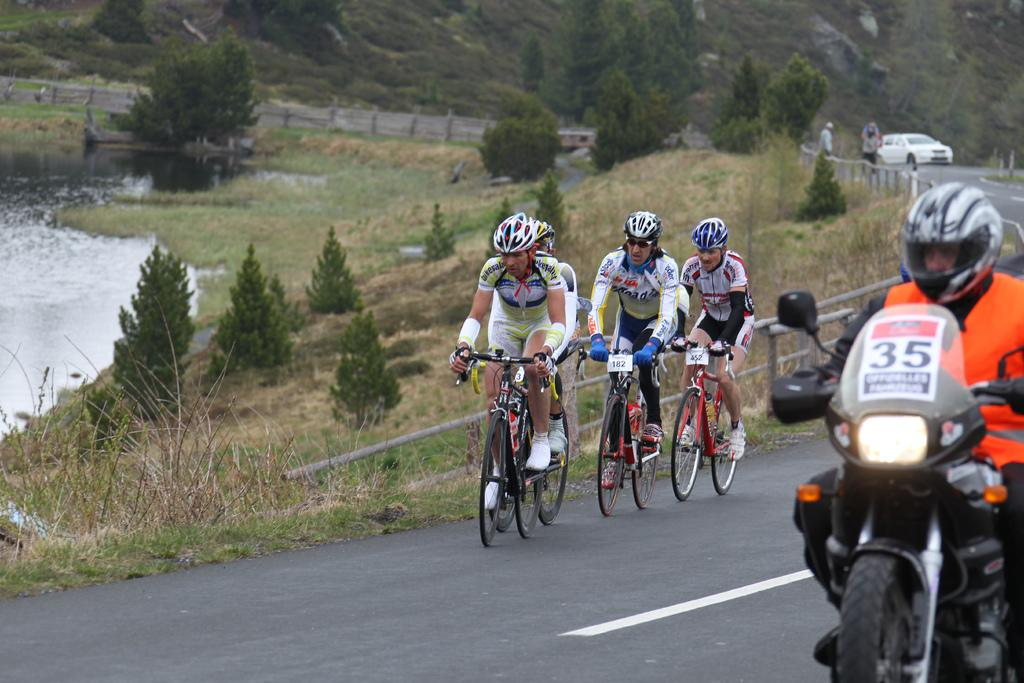What type of protective gear are the people wearing in the image? The people in the image are wearing helmets. What are the people doing while wearing helmets? Some people are riding bicycles, and some are riding motorcycles. What type of natural environment is visible in the image? There are trees, grass, water, and hills visible in the image. What type of man-made structure can be seen in the image? There is a fence in the image. What type of vehicle is present in the image? There is a white color car in the image. What type of juice is being served at the event in the image? There is no event or juice present in the image. How many days are represented in the image? The image does not represent any specific day or week. 